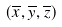Convert formula to latex. <formula><loc_0><loc_0><loc_500><loc_500>( \overline { x } , \overline { y } , \overline { z } )</formula> 